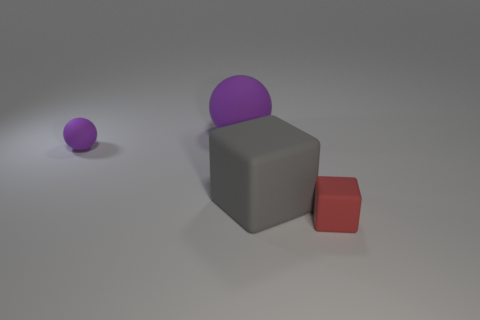Add 1 big matte spheres. How many objects exist? 5 Subtract all red matte blocks. Subtract all tiny green shiny cylinders. How many objects are left? 3 Add 4 rubber things. How many rubber things are left? 8 Add 4 blue metal balls. How many blue metal balls exist? 4 Subtract 1 gray blocks. How many objects are left? 3 